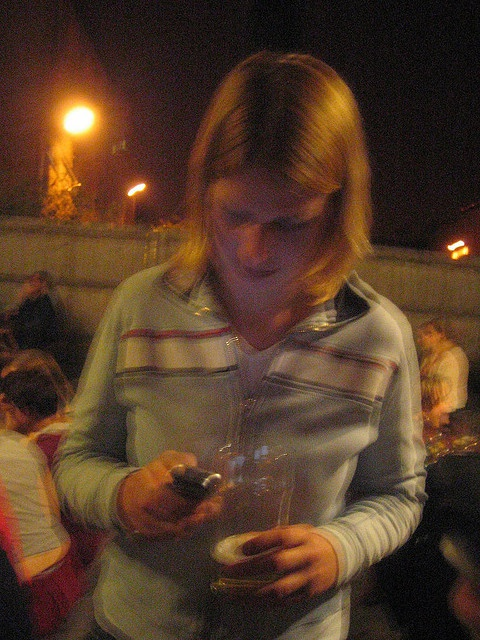Describe the objects in this image and their specific colors. I can see people in black, maroon, olive, and gray tones, people in black, maroon, and olive tones, cup in black, maroon, and brown tones, people in black, brown, orange, and maroon tones, and people in black, maroon, and purple tones in this image. 